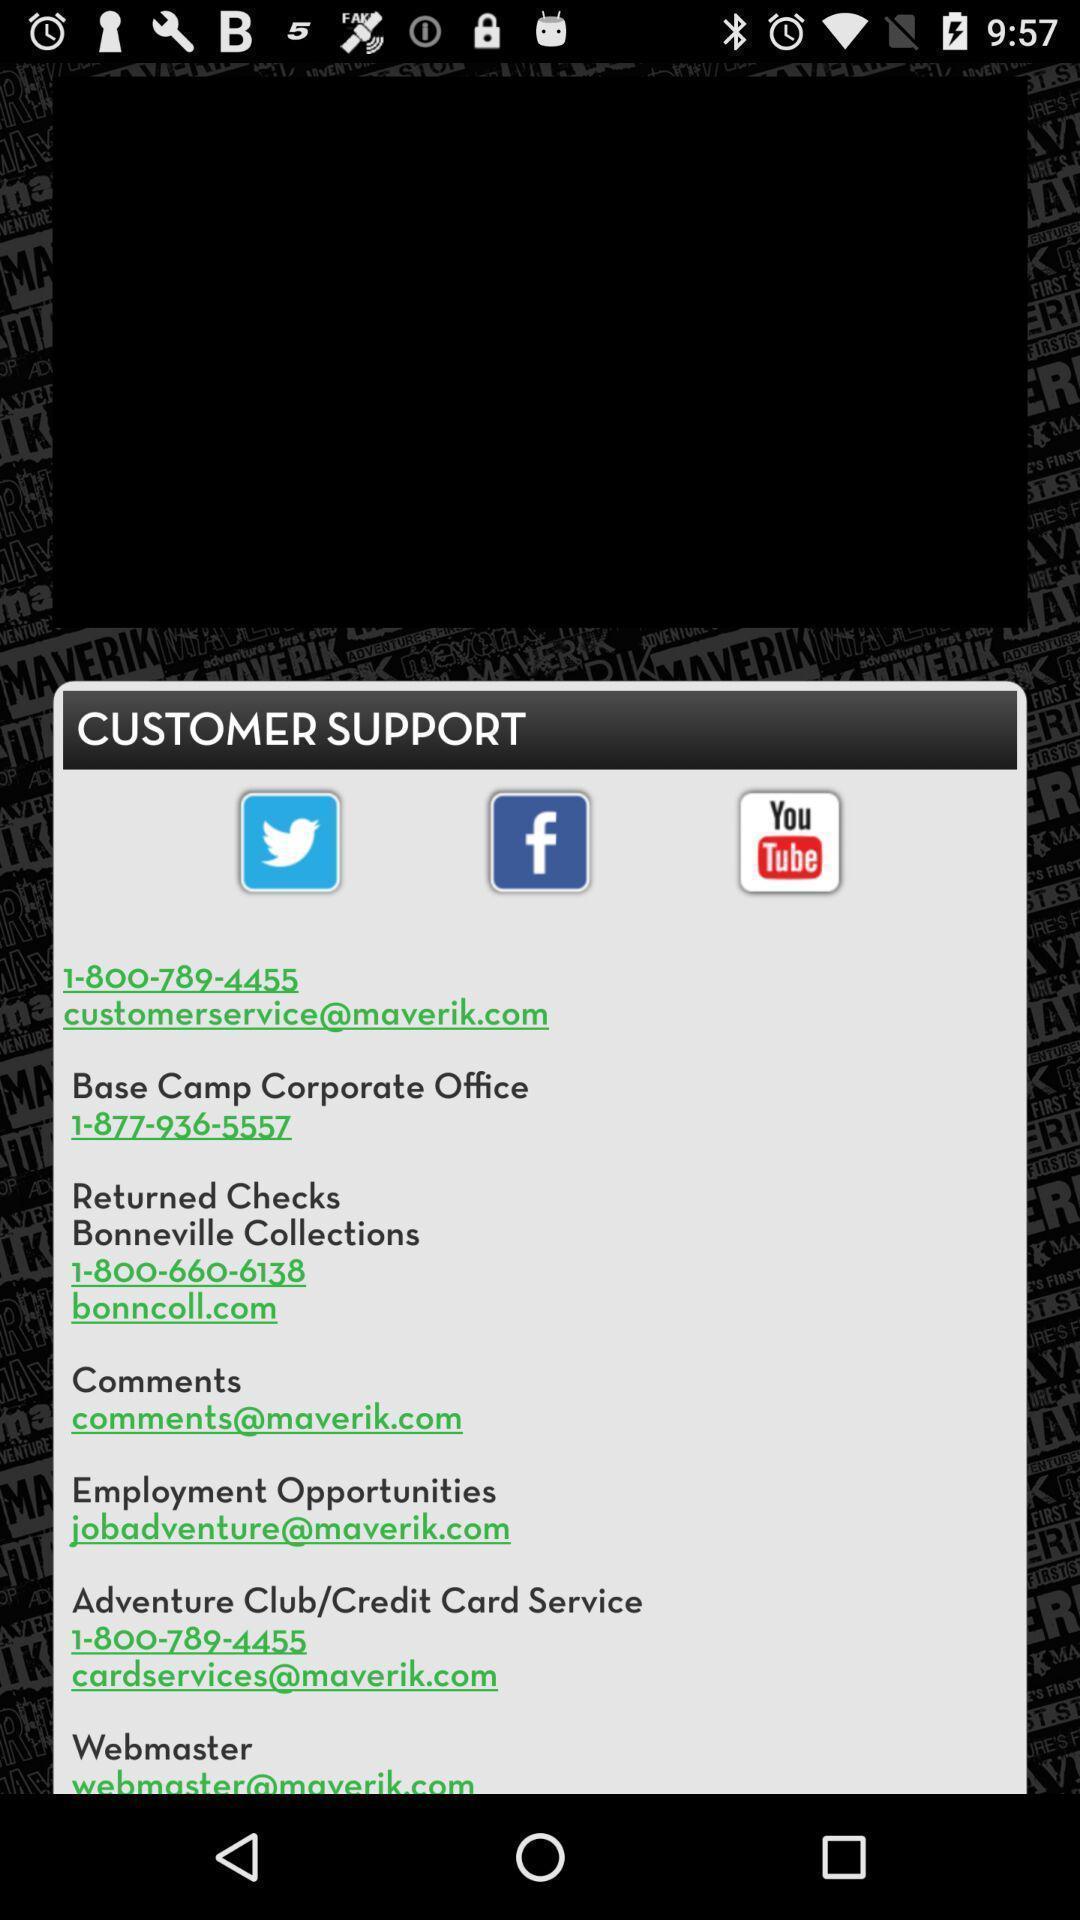What is the overall content of this screenshot? Pop-up for customer support information. 